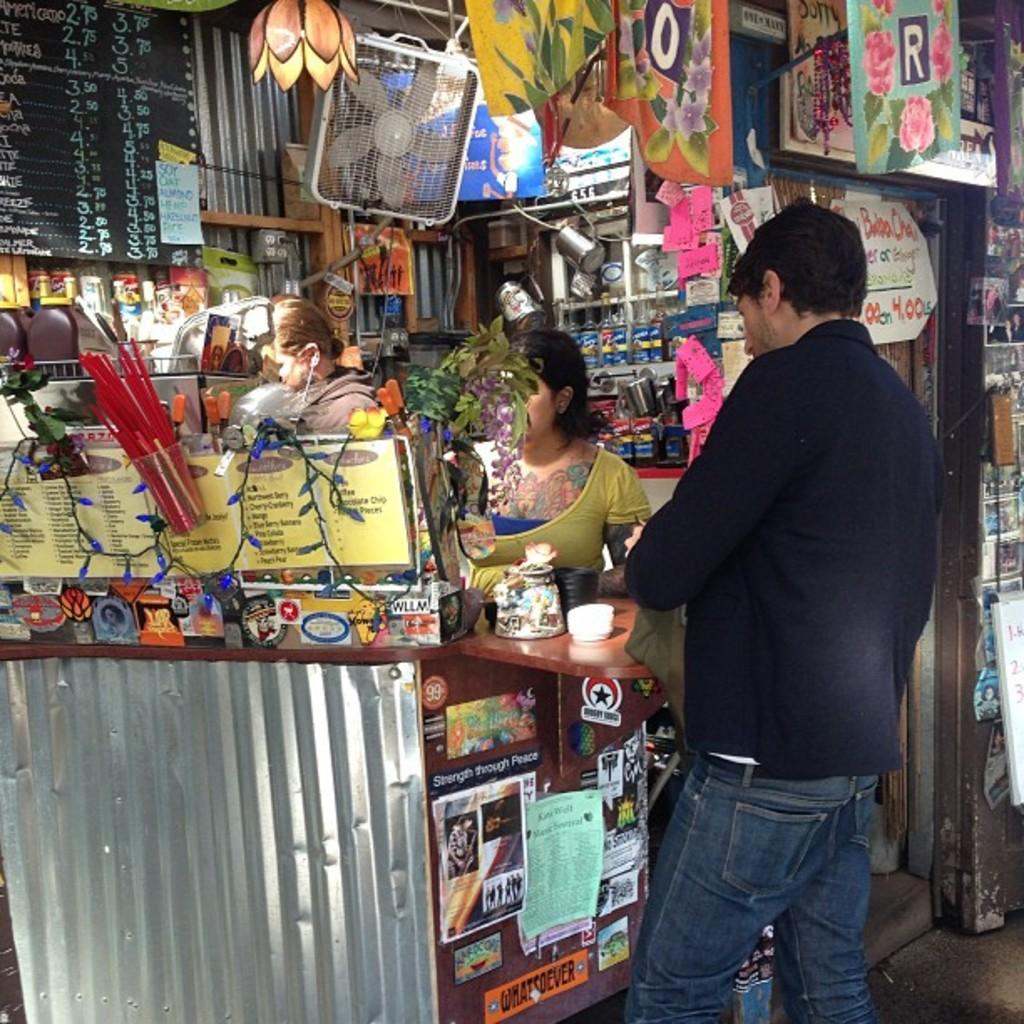<image>
Present a compact description of the photo's key features. Among the stickers placed on the side of the counter is one which has the motto Strength through Peace. 